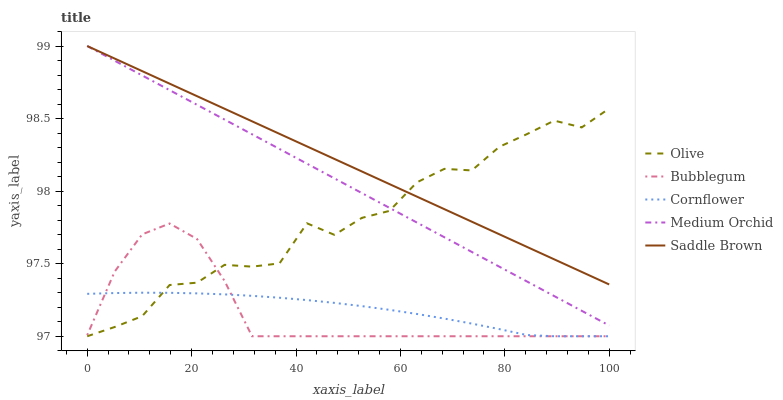Does Bubblegum have the minimum area under the curve?
Answer yes or no. Yes. Does Saddle Brown have the maximum area under the curve?
Answer yes or no. Yes. Does Cornflower have the minimum area under the curve?
Answer yes or no. No. Does Cornflower have the maximum area under the curve?
Answer yes or no. No. Is Saddle Brown the smoothest?
Answer yes or no. Yes. Is Olive the roughest?
Answer yes or no. Yes. Is Cornflower the smoothest?
Answer yes or no. No. Is Cornflower the roughest?
Answer yes or no. No. Does Olive have the lowest value?
Answer yes or no. Yes. Does Medium Orchid have the lowest value?
Answer yes or no. No. Does Saddle Brown have the highest value?
Answer yes or no. Yes. Does Cornflower have the highest value?
Answer yes or no. No. Is Cornflower less than Saddle Brown?
Answer yes or no. Yes. Is Saddle Brown greater than Cornflower?
Answer yes or no. Yes. Does Bubblegum intersect Olive?
Answer yes or no. Yes. Is Bubblegum less than Olive?
Answer yes or no. No. Is Bubblegum greater than Olive?
Answer yes or no. No. Does Cornflower intersect Saddle Brown?
Answer yes or no. No. 